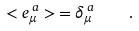<formula> <loc_0><loc_0><loc_500><loc_500>< e _ { \mu } ^ { \, a } > \, = \delta _ { \mu } ^ { \, a } \quad .</formula> 